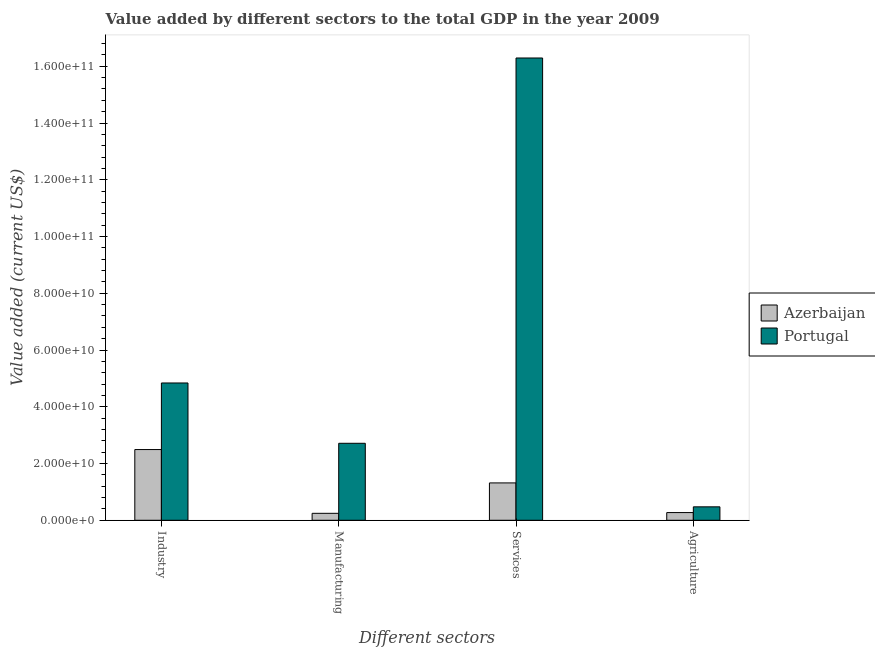Are the number of bars per tick equal to the number of legend labels?
Keep it short and to the point. Yes. Are the number of bars on each tick of the X-axis equal?
Offer a very short reply. Yes. How many bars are there on the 3rd tick from the right?
Provide a short and direct response. 2. What is the label of the 2nd group of bars from the left?
Ensure brevity in your answer.  Manufacturing. What is the value added by industrial sector in Portugal?
Provide a succinct answer. 4.84e+1. Across all countries, what is the maximum value added by services sector?
Keep it short and to the point. 1.63e+11. Across all countries, what is the minimum value added by industrial sector?
Make the answer very short. 2.49e+1. In which country was the value added by services sector maximum?
Your response must be concise. Portugal. In which country was the value added by manufacturing sector minimum?
Your response must be concise. Azerbaijan. What is the total value added by industrial sector in the graph?
Provide a short and direct response. 7.33e+1. What is the difference between the value added by industrial sector in Azerbaijan and that in Portugal?
Offer a terse response. -2.35e+1. What is the difference between the value added by manufacturing sector in Azerbaijan and the value added by agricultural sector in Portugal?
Your answer should be very brief. -2.29e+09. What is the average value added by agricultural sector per country?
Offer a terse response. 3.72e+09. What is the difference between the value added by manufacturing sector and value added by agricultural sector in Portugal?
Your response must be concise. 2.24e+1. What is the ratio of the value added by industrial sector in Azerbaijan to that in Portugal?
Give a very brief answer. 0.52. Is the difference between the value added by manufacturing sector in Azerbaijan and Portugal greater than the difference between the value added by services sector in Azerbaijan and Portugal?
Your response must be concise. Yes. What is the difference between the highest and the second highest value added by services sector?
Offer a very short reply. 1.50e+11. What is the difference between the highest and the lowest value added by services sector?
Offer a very short reply. 1.50e+11. In how many countries, is the value added by industrial sector greater than the average value added by industrial sector taken over all countries?
Offer a very short reply. 1. Is it the case that in every country, the sum of the value added by manufacturing sector and value added by industrial sector is greater than the sum of value added by services sector and value added by agricultural sector?
Ensure brevity in your answer.  No. What does the 1st bar from the left in Manufacturing represents?
Your response must be concise. Azerbaijan. Is it the case that in every country, the sum of the value added by industrial sector and value added by manufacturing sector is greater than the value added by services sector?
Your answer should be compact. No. Are all the bars in the graph horizontal?
Ensure brevity in your answer.  No. Are the values on the major ticks of Y-axis written in scientific E-notation?
Keep it short and to the point. Yes. Does the graph contain any zero values?
Your answer should be very brief. No. Where does the legend appear in the graph?
Provide a succinct answer. Center right. How many legend labels are there?
Provide a short and direct response. 2. What is the title of the graph?
Offer a very short reply. Value added by different sectors to the total GDP in the year 2009. Does "French Polynesia" appear as one of the legend labels in the graph?
Provide a succinct answer. No. What is the label or title of the X-axis?
Make the answer very short. Different sectors. What is the label or title of the Y-axis?
Give a very brief answer. Value added (current US$). What is the Value added (current US$) of Azerbaijan in Industry?
Offer a very short reply. 2.49e+1. What is the Value added (current US$) of Portugal in Industry?
Make the answer very short. 4.84e+1. What is the Value added (current US$) in Azerbaijan in Manufacturing?
Provide a succinct answer. 2.45e+09. What is the Value added (current US$) of Portugal in Manufacturing?
Your answer should be compact. 2.71e+1. What is the Value added (current US$) in Azerbaijan in Services?
Your answer should be compact. 1.32e+1. What is the Value added (current US$) of Portugal in Services?
Your response must be concise. 1.63e+11. What is the Value added (current US$) of Azerbaijan in Agriculture?
Offer a very short reply. 2.71e+09. What is the Value added (current US$) in Portugal in Agriculture?
Your answer should be compact. 4.74e+09. Across all Different sectors, what is the maximum Value added (current US$) of Azerbaijan?
Keep it short and to the point. 2.49e+1. Across all Different sectors, what is the maximum Value added (current US$) of Portugal?
Provide a succinct answer. 1.63e+11. Across all Different sectors, what is the minimum Value added (current US$) in Azerbaijan?
Offer a terse response. 2.45e+09. Across all Different sectors, what is the minimum Value added (current US$) in Portugal?
Your answer should be very brief. 4.74e+09. What is the total Value added (current US$) in Azerbaijan in the graph?
Your answer should be very brief. 4.32e+1. What is the total Value added (current US$) of Portugal in the graph?
Your answer should be very brief. 2.43e+11. What is the difference between the Value added (current US$) in Azerbaijan in Industry and that in Manufacturing?
Your answer should be very brief. 2.25e+1. What is the difference between the Value added (current US$) of Portugal in Industry and that in Manufacturing?
Keep it short and to the point. 2.13e+1. What is the difference between the Value added (current US$) in Azerbaijan in Industry and that in Services?
Provide a short and direct response. 1.18e+1. What is the difference between the Value added (current US$) in Portugal in Industry and that in Services?
Give a very brief answer. -1.15e+11. What is the difference between the Value added (current US$) of Azerbaijan in Industry and that in Agriculture?
Give a very brief answer. 2.22e+1. What is the difference between the Value added (current US$) in Portugal in Industry and that in Agriculture?
Ensure brevity in your answer.  4.36e+1. What is the difference between the Value added (current US$) in Azerbaijan in Manufacturing and that in Services?
Offer a very short reply. -1.07e+1. What is the difference between the Value added (current US$) of Portugal in Manufacturing and that in Services?
Make the answer very short. -1.36e+11. What is the difference between the Value added (current US$) of Azerbaijan in Manufacturing and that in Agriculture?
Ensure brevity in your answer.  -2.64e+08. What is the difference between the Value added (current US$) of Portugal in Manufacturing and that in Agriculture?
Offer a terse response. 2.24e+1. What is the difference between the Value added (current US$) in Azerbaijan in Services and that in Agriculture?
Offer a terse response. 1.05e+1. What is the difference between the Value added (current US$) of Portugal in Services and that in Agriculture?
Provide a succinct answer. 1.58e+11. What is the difference between the Value added (current US$) in Azerbaijan in Industry and the Value added (current US$) in Portugal in Manufacturing?
Provide a short and direct response. -2.21e+09. What is the difference between the Value added (current US$) of Azerbaijan in Industry and the Value added (current US$) of Portugal in Services?
Your answer should be compact. -1.38e+11. What is the difference between the Value added (current US$) in Azerbaijan in Industry and the Value added (current US$) in Portugal in Agriculture?
Make the answer very short. 2.02e+1. What is the difference between the Value added (current US$) in Azerbaijan in Manufacturing and the Value added (current US$) in Portugal in Services?
Your answer should be compact. -1.60e+11. What is the difference between the Value added (current US$) in Azerbaijan in Manufacturing and the Value added (current US$) in Portugal in Agriculture?
Make the answer very short. -2.29e+09. What is the difference between the Value added (current US$) of Azerbaijan in Services and the Value added (current US$) of Portugal in Agriculture?
Offer a terse response. 8.43e+09. What is the average Value added (current US$) in Azerbaijan per Different sectors?
Give a very brief answer. 1.08e+1. What is the average Value added (current US$) in Portugal per Different sectors?
Provide a succinct answer. 6.08e+1. What is the difference between the Value added (current US$) in Azerbaijan and Value added (current US$) in Portugal in Industry?
Provide a succinct answer. -2.35e+1. What is the difference between the Value added (current US$) in Azerbaijan and Value added (current US$) in Portugal in Manufacturing?
Your answer should be compact. -2.47e+1. What is the difference between the Value added (current US$) of Azerbaijan and Value added (current US$) of Portugal in Services?
Your response must be concise. -1.50e+11. What is the difference between the Value added (current US$) of Azerbaijan and Value added (current US$) of Portugal in Agriculture?
Provide a succinct answer. -2.02e+09. What is the ratio of the Value added (current US$) of Azerbaijan in Industry to that in Manufacturing?
Keep it short and to the point. 10.18. What is the ratio of the Value added (current US$) of Portugal in Industry to that in Manufacturing?
Provide a succinct answer. 1.78. What is the ratio of the Value added (current US$) in Azerbaijan in Industry to that in Services?
Provide a succinct answer. 1.89. What is the ratio of the Value added (current US$) in Portugal in Industry to that in Services?
Offer a very short reply. 0.3. What is the ratio of the Value added (current US$) of Azerbaijan in Industry to that in Agriculture?
Keep it short and to the point. 9.19. What is the ratio of the Value added (current US$) of Portugal in Industry to that in Agriculture?
Ensure brevity in your answer.  10.22. What is the ratio of the Value added (current US$) in Azerbaijan in Manufacturing to that in Services?
Make the answer very short. 0.19. What is the ratio of the Value added (current US$) of Portugal in Manufacturing to that in Services?
Ensure brevity in your answer.  0.17. What is the ratio of the Value added (current US$) in Azerbaijan in Manufacturing to that in Agriculture?
Give a very brief answer. 0.9. What is the ratio of the Value added (current US$) of Portugal in Manufacturing to that in Agriculture?
Offer a terse response. 5.73. What is the ratio of the Value added (current US$) in Azerbaijan in Services to that in Agriculture?
Offer a terse response. 4.86. What is the ratio of the Value added (current US$) in Portugal in Services to that in Agriculture?
Provide a short and direct response. 34.4. What is the difference between the highest and the second highest Value added (current US$) in Azerbaijan?
Ensure brevity in your answer.  1.18e+1. What is the difference between the highest and the second highest Value added (current US$) of Portugal?
Your response must be concise. 1.15e+11. What is the difference between the highest and the lowest Value added (current US$) of Azerbaijan?
Make the answer very short. 2.25e+1. What is the difference between the highest and the lowest Value added (current US$) of Portugal?
Provide a short and direct response. 1.58e+11. 